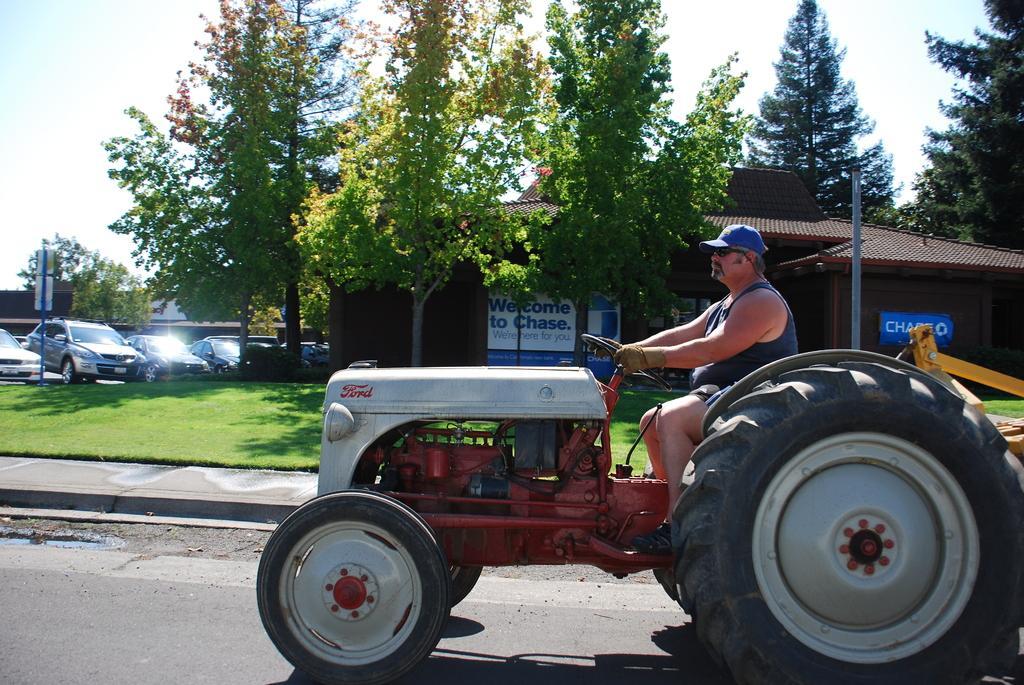How would you summarize this image in a sentence or two? There is a person wearing cap goggles and gloves is sitting on a tractor. And there is a road. Near to the road there is a sidewalk. On the ground there is grass. In the back there are vehicles, trees and buildings with banners. In the background there is sky. 